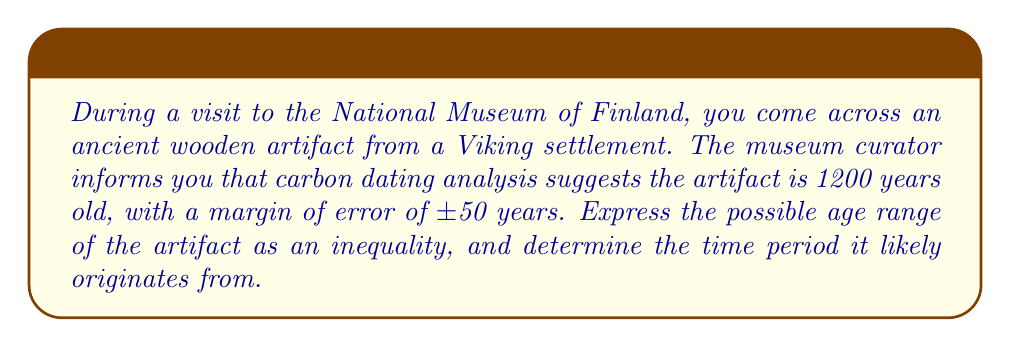Could you help me with this problem? Let's approach this step-by-step:

1) The estimated age is 1200 years, with a margin of error of ±50 years.

2) This means the actual age could be up to 50 years more or less than 1200.

3) We can express this as an inequality:
   $$ 1200 - 50 \leq x \leq 1200 + 50 $$
   where $x$ represents the actual age in years.

4) Simplifying:
   $$ 1150 \leq x \leq 1250 $$

5) To determine the time period, we need to subtract these years from the current year. Let's assume the current year is 2023.

6) The possible range of years when the artifact was created:
   $$ 2023 - 1250 \leq \text{Year created} \leq 2023 - 1150 $$
   $$ 773 \leq \text{Year created} \leq 873 $$

7) This period (773 CE to 873 CE) corresponds to the early Viking Age, which historically spans from about 793 CE to 1066 CE.
Answer: $1150 \leq x \leq 1250$ years ago; Early Viking Age (773-873 CE) 